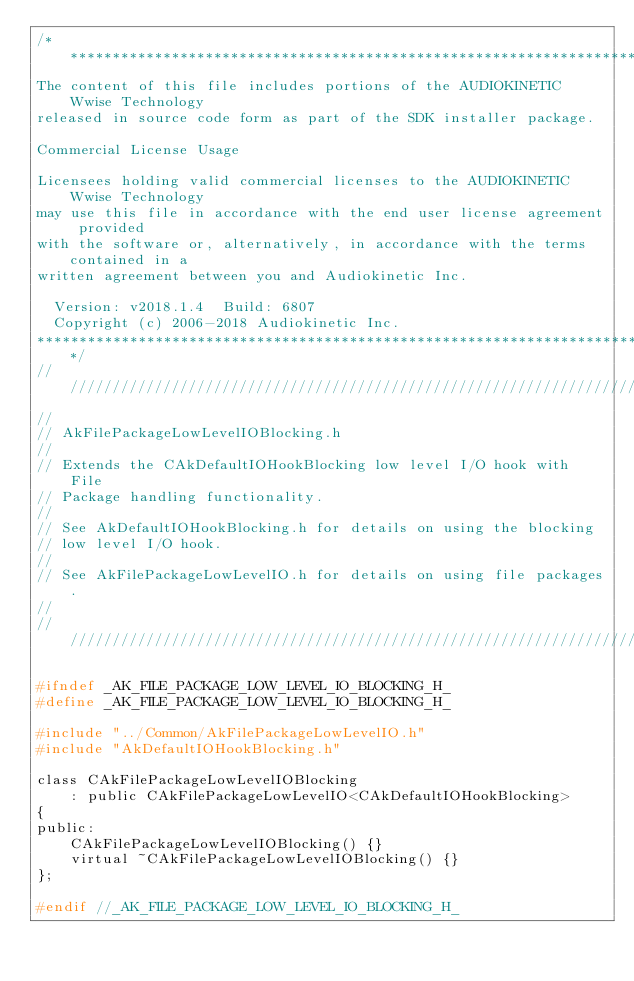<code> <loc_0><loc_0><loc_500><loc_500><_C_>/*******************************************************************************
The content of this file includes portions of the AUDIOKINETIC Wwise Technology
released in source code form as part of the SDK installer package.

Commercial License Usage

Licensees holding valid commercial licenses to the AUDIOKINETIC Wwise Technology
may use this file in accordance with the end user license agreement provided 
with the software or, alternatively, in accordance with the terms contained in a
written agreement between you and Audiokinetic Inc.

  Version: v2018.1.4  Build: 6807
  Copyright (c) 2006-2018 Audiokinetic Inc.
*******************************************************************************/
//////////////////////////////////////////////////////////////////////
//
// AkFilePackageLowLevelIOBlocking.h
//
// Extends the CAkDefaultIOHookBlocking low level I/O hook with File 
// Package handling functionality. 
//
// See AkDefaultIOHookBlocking.h for details on using the blocking 
// low level I/O hook. 
// 
// See AkFilePackageLowLevelIO.h for details on using file packages.
//
//////////////////////////////////////////////////////////////////////

#ifndef _AK_FILE_PACKAGE_LOW_LEVEL_IO_BLOCKING_H_
#define _AK_FILE_PACKAGE_LOW_LEVEL_IO_BLOCKING_H_

#include "../Common/AkFilePackageLowLevelIO.h"
#include "AkDefaultIOHookBlocking.h"

class CAkFilePackageLowLevelIOBlocking 
	: public CAkFilePackageLowLevelIO<CAkDefaultIOHookBlocking>
{
public:
	CAkFilePackageLowLevelIOBlocking() {}
	virtual ~CAkFilePackageLowLevelIOBlocking() {}
};

#endif //_AK_FILE_PACKAGE_LOW_LEVEL_IO_BLOCKING_H_
</code> 